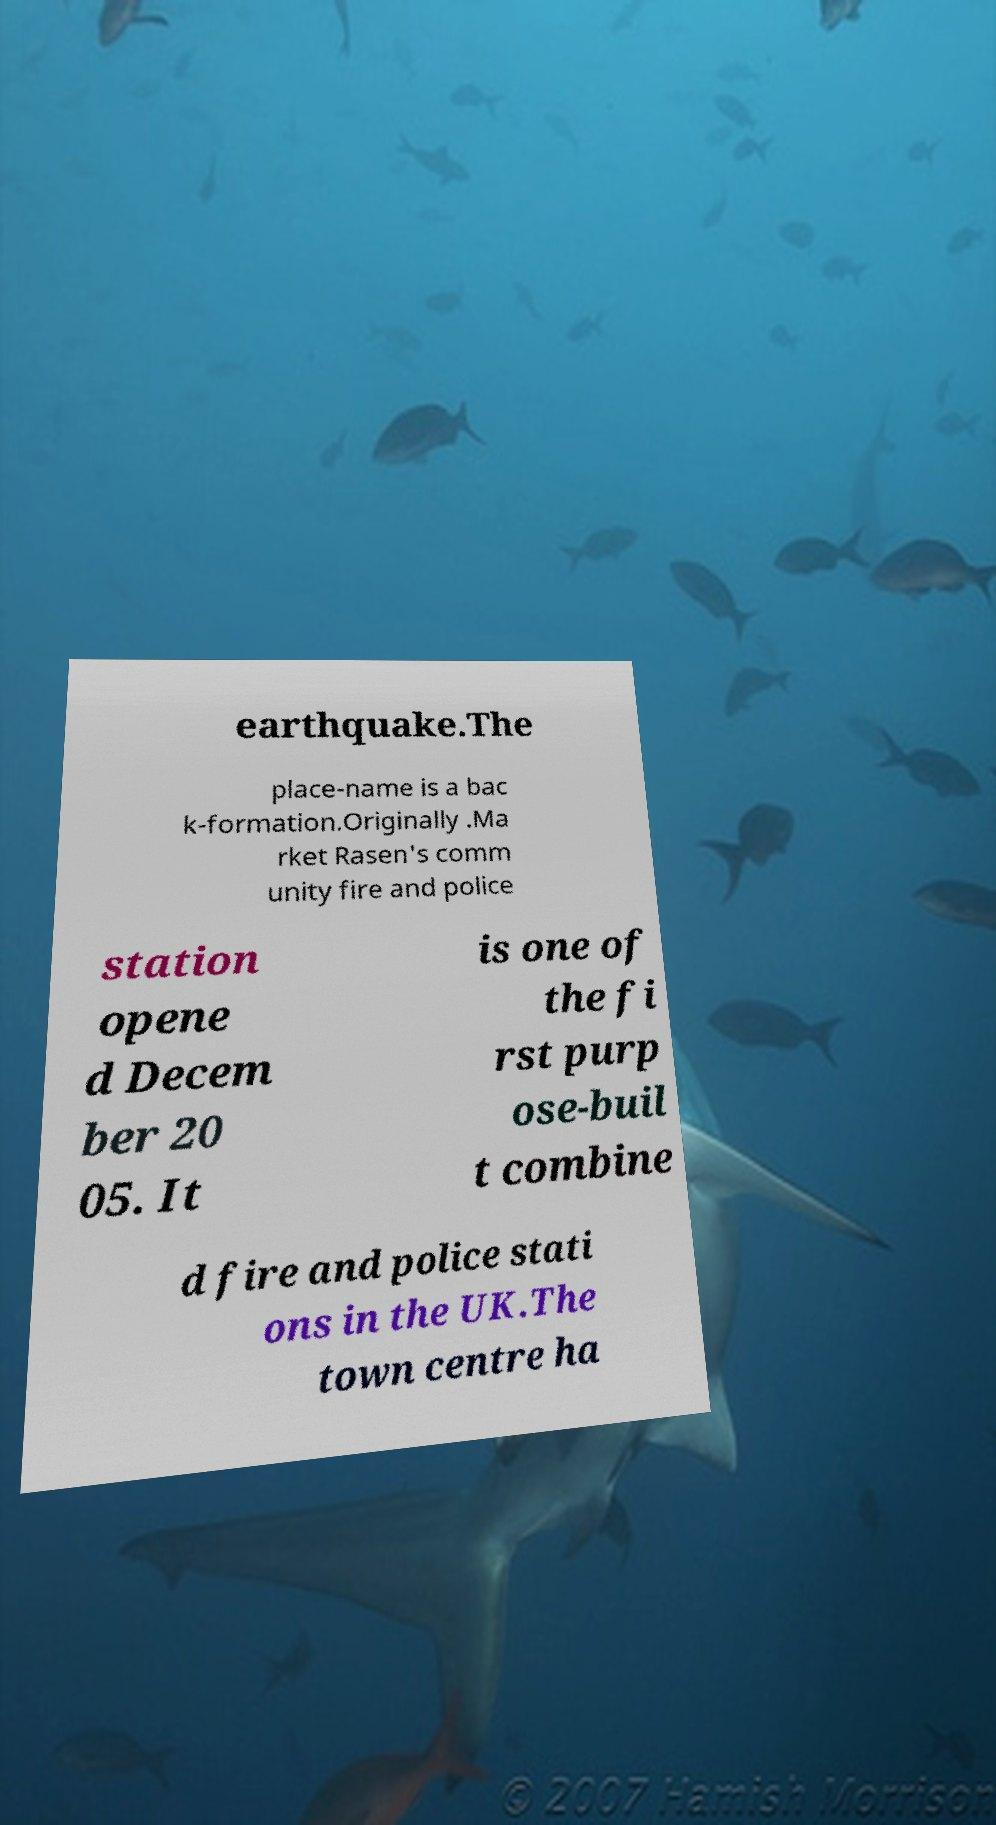There's text embedded in this image that I need extracted. Can you transcribe it verbatim? earthquake.The place-name is a bac k-formation.Originally .Ma rket Rasen's comm unity fire and police station opene d Decem ber 20 05. It is one of the fi rst purp ose-buil t combine d fire and police stati ons in the UK.The town centre ha 